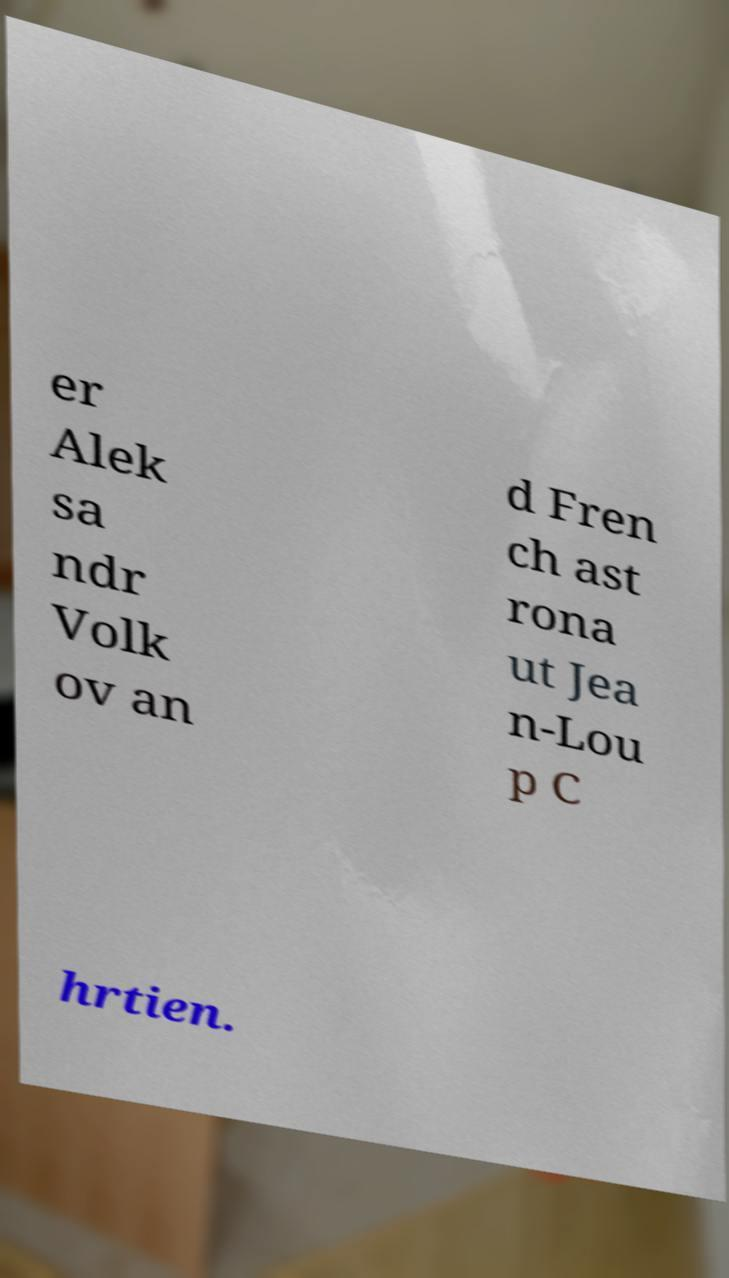There's text embedded in this image that I need extracted. Can you transcribe it verbatim? er Alek sa ndr Volk ov an d Fren ch ast rona ut Jea n-Lou p C hrtien. 